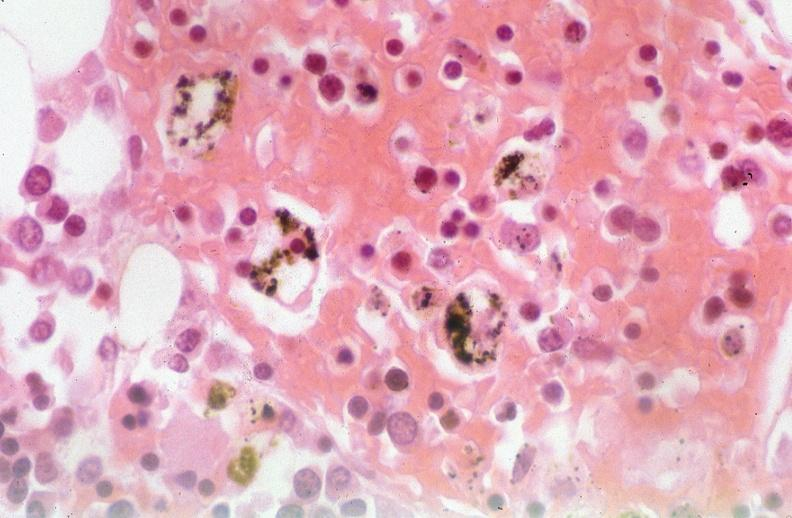what was talc used, alpha-1 antitrypsin deficiency?
Answer the question using a single word or phrase. Used to sclerose emphysematous lung 